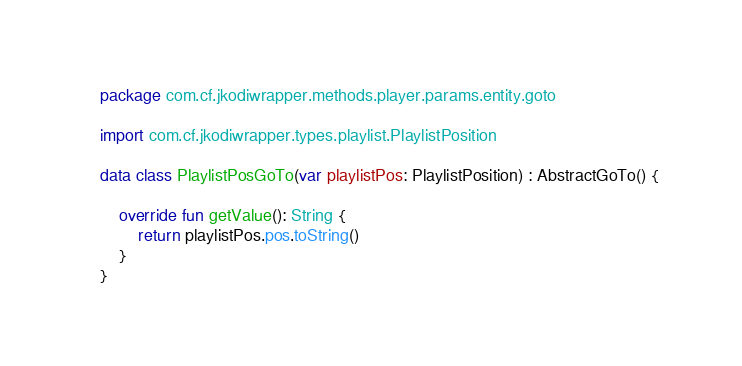<code> <loc_0><loc_0><loc_500><loc_500><_Kotlin_>package com.cf.jkodiwrapper.methods.player.params.entity.goto

import com.cf.jkodiwrapper.types.playlist.PlaylistPosition

data class PlaylistPosGoTo(var playlistPos: PlaylistPosition) : AbstractGoTo() {

    override fun getValue(): String {
        return playlistPos.pos.toString()
    }
}</code> 